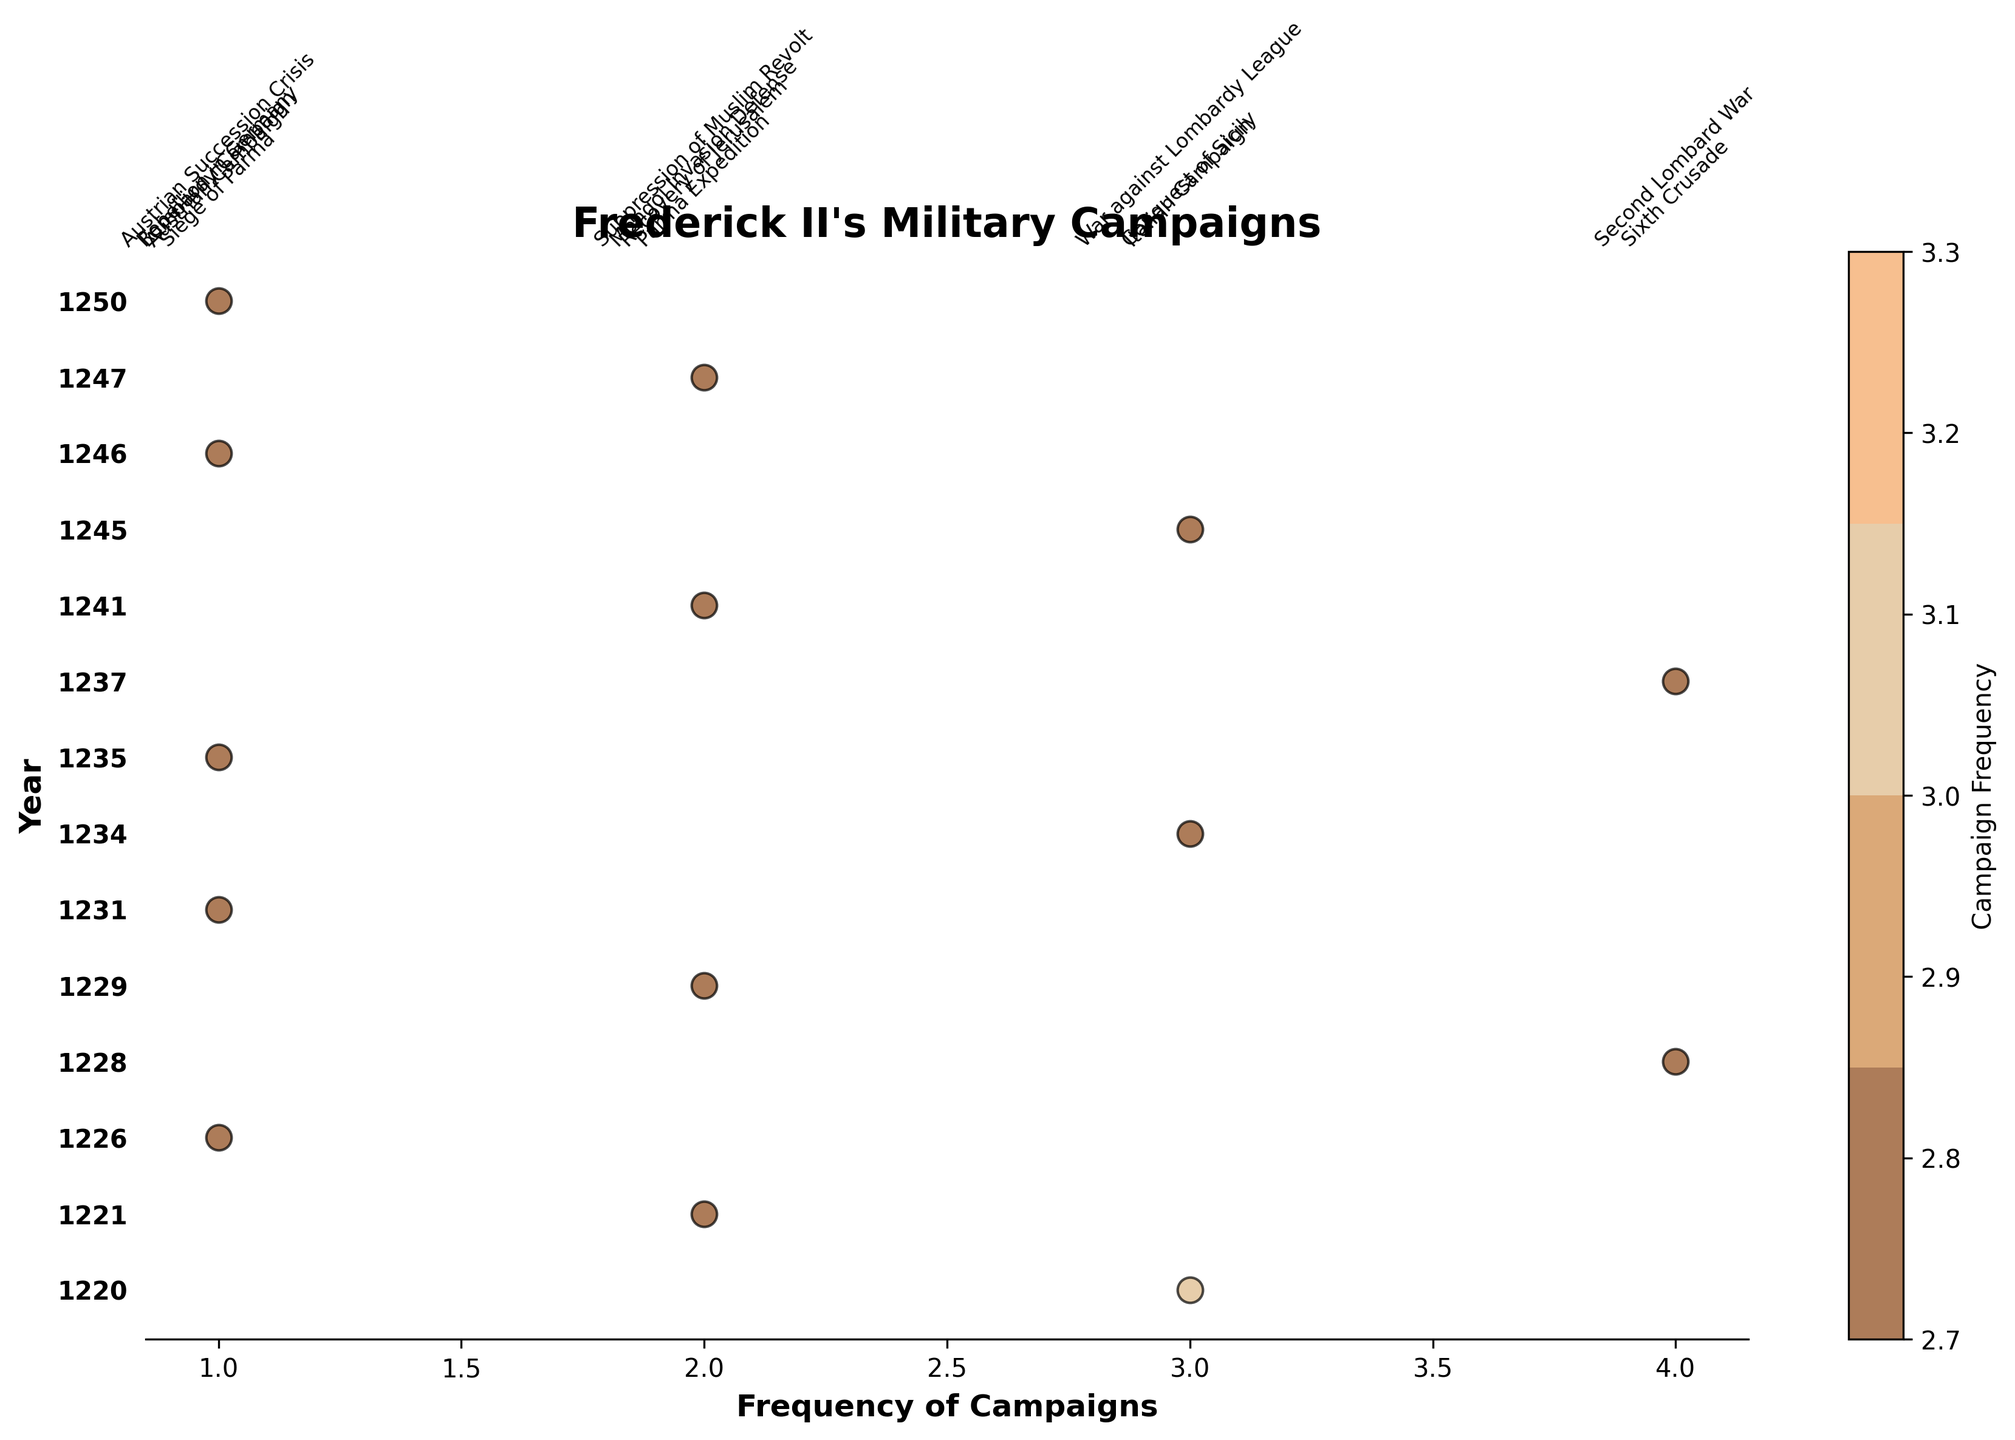what is the title of the plot? The title is typically displayed at the top of the plot. It provides a concise summary of the plot's content.
Answer: Frederick II's Military Campaigns How many years are represented in the plot? The number of years can be determined by counting the unique labels on the y-axis. Each label corresponds to a different year.
Answer: 14 Which year had the highest frequency of military campaigns? Look for the year with the highest numeric value on the x-axis among the scatter points, then identify its corresponding y-axis label.
Answer: 1228 and 1237 What is the frequency of military campaigns in the year 1234? Locate the y-axis label for the year 1234 and find the numeric value directly adjacent to it on the x-axis.
Answer: 3 How many campaigns were there in the year 1220? Look at the y-axis label for 1220 and check the corresponding scatter points on the x-axis to count the number of campaigns.
Answer: 3 What is the frequency difference between the campaigns in 1221 and 1241? Locate the y-axis labels for 1221 and 1241, then subtract the frequency value of 1221 from that of 1241.
Answer: 0 Are there more campaigns in the 1220s or the 1240s? Sum the frequencies for years in the 1220s (1220, 1221, 1226, 1228, 1229) and the 1240s (1241, 1245, 1246, 1247, 1250) and compare the total values.
Answer: 1220s Which year had a frequency of 4 campaigns and which campaigns were these? Identify the scatter points with a frequency value of 4 and check their corresponding y-axis labels to find the year. Then, look at the annotations for that year to determine the campaigns.
Answer: 1228: Sixth Crusade, 1237: Second Lombard War How does the campaign frequency in 1237 compare to that in 1231? Locate the y-axis labels for 1237 and 1231 and compare their corresponding frequency values on the x-axis.
Answer: 1237's frequency is greater than 1231's What was the frequency of campaigns for the Austrian Campaign? Find the annotation for the "Austrian Campaign" and check its corresponding x-axis value for frequency.
Answer: 1 